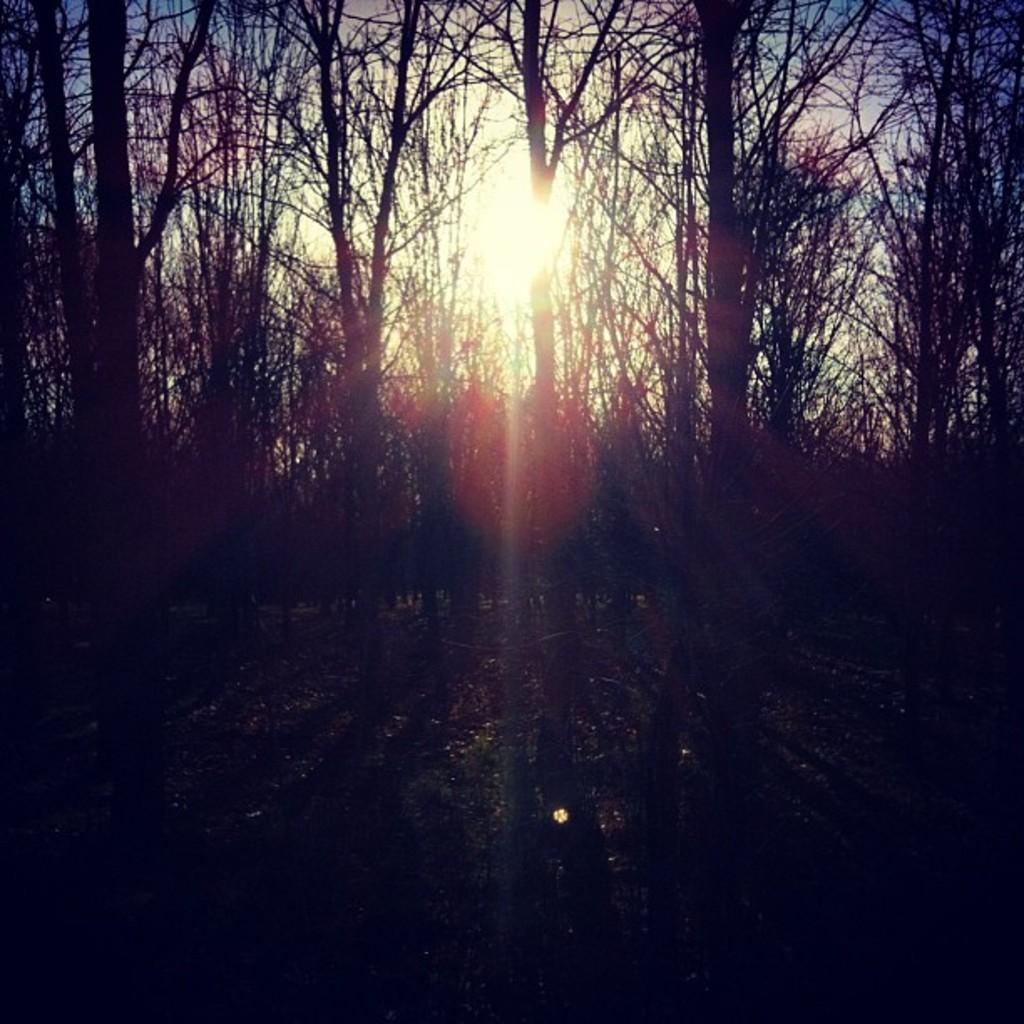What type of vegetation can be seen in the image? There are trees in the image. What part of the natural environment is visible in the image? The sky is visible in the background of the image. What type of tomatoes are growing on the trees in the image? There are no tomatoes present in the image, as the trees are not fruit-bearing trees. 